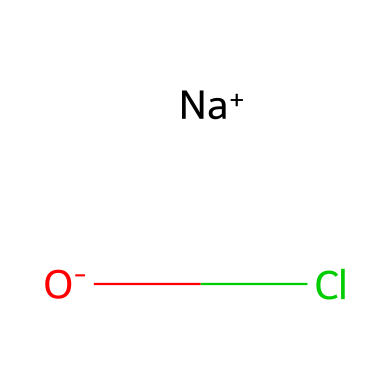What is the central atom in this chemical structure? The chemical structure shows sodium (Na) as a central atom because it is positively charged, indicating that it's the cation in this ionic compound.
Answer: sodium How many atoms of chlorine are present? The structure indicates one chlorine atom is present, represented by Cl in the SMILES notation without any numerical indication of multiples.
Answer: 1 What type of chemical bond is present in this compound? The presence of a sodium cation and a chloride anion suggests an ionic bond, as cations and anions attract each other due to opposite charges.
Answer: ionic What is the charge of the chloride ion here? The notation shows that chlorine has a negative charge (O-) indicating it is an anion, which results from gaining an electron.
Answer: negative Is this compound an electrolyte? Yes, this compound is an electrolyte because it dissociates into ions in solution, which can conduct electricity, fulfilling the definition of electrolytes.
Answer: yes What is the formula for this molecule? The SMILES representation contains both sodium and chloride ions, which combines to represent the formula NaCl for table salt, commonly used in household cleaning agents.
Answer: NaCl How many total atoms are in this chemical? The chemical contains two atoms, with one sodium and one chlorine, which sums up to a total of two atoms.
Answer: 2 